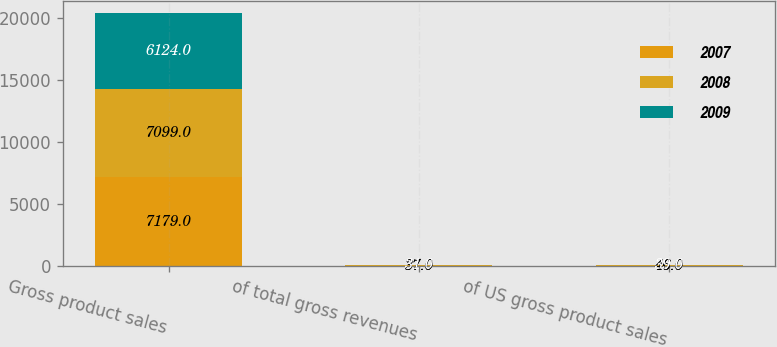<chart> <loc_0><loc_0><loc_500><loc_500><stacked_bar_chart><ecel><fcel>Gross product sales<fcel>of total gross revenues<fcel>of US gross product sales<nl><fcel>2007<fcel>7179<fcel>37<fcel>46<nl><fcel>2008<fcel>7099<fcel>37<fcel>46<nl><fcel>2009<fcel>6124<fcel>31<fcel>39<nl></chart> 